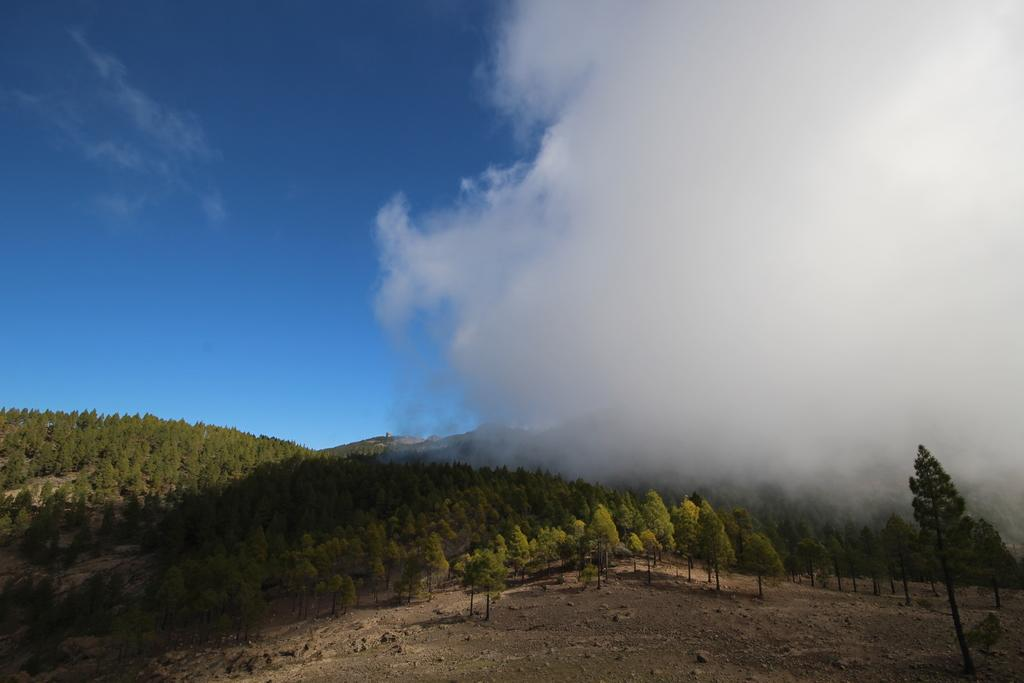What can be seen in the sky in the image? The sky with clouds is visible in the image. What type of vegetation is present in the image? There are trees in the image. What is the surface visible in the image? The ground is visible in the image. What is the profit margin of the trees in the image? There is no information about profit margins in the image, as it features natural elements like the sky, trees, and ground. 